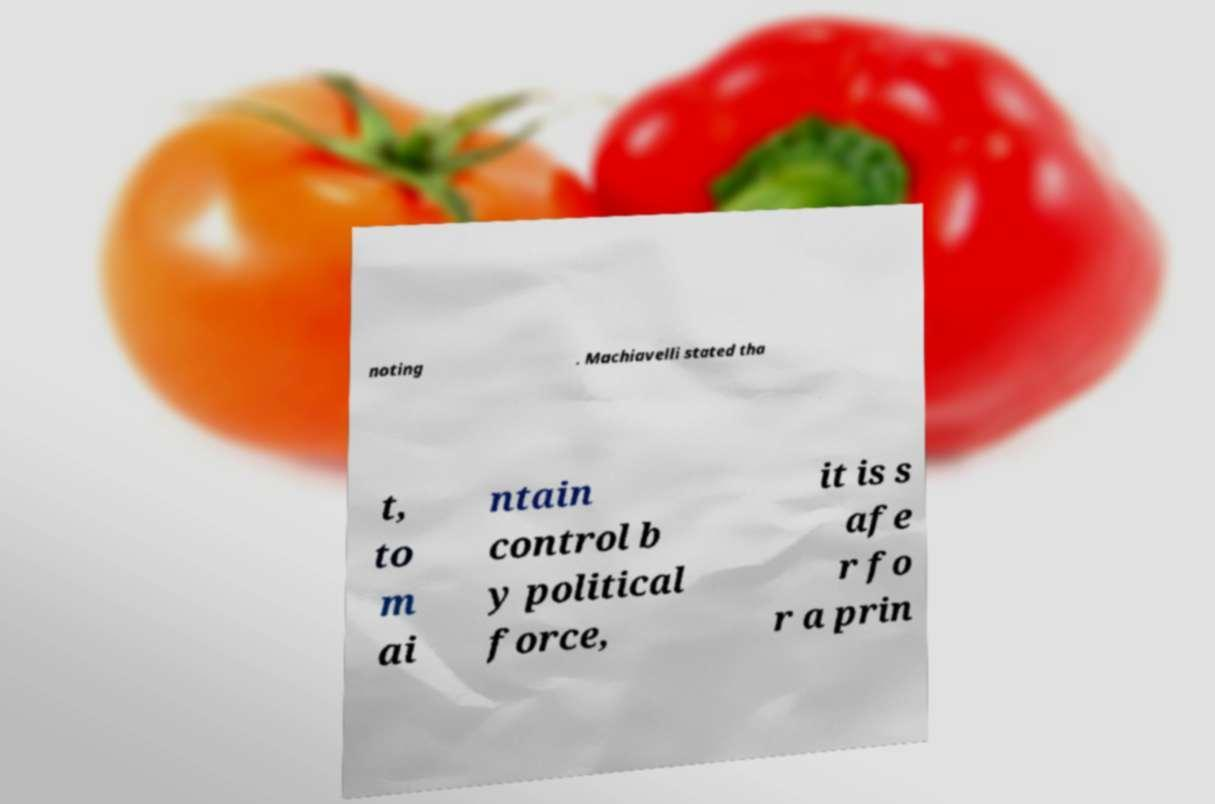I need the written content from this picture converted into text. Can you do that? noting . Machiavelli stated tha t, to m ai ntain control b y political force, it is s afe r fo r a prin 